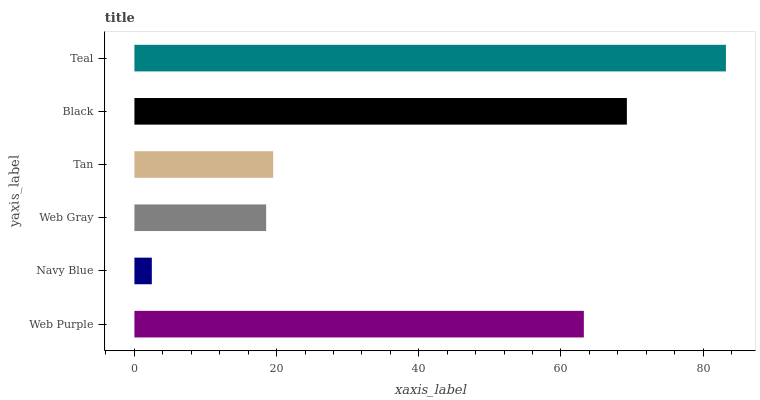Is Navy Blue the minimum?
Answer yes or no. Yes. Is Teal the maximum?
Answer yes or no. Yes. Is Web Gray the minimum?
Answer yes or no. No. Is Web Gray the maximum?
Answer yes or no. No. Is Web Gray greater than Navy Blue?
Answer yes or no. Yes. Is Navy Blue less than Web Gray?
Answer yes or no. Yes. Is Navy Blue greater than Web Gray?
Answer yes or no. No. Is Web Gray less than Navy Blue?
Answer yes or no. No. Is Web Purple the high median?
Answer yes or no. Yes. Is Tan the low median?
Answer yes or no. Yes. Is Tan the high median?
Answer yes or no. No. Is Teal the low median?
Answer yes or no. No. 